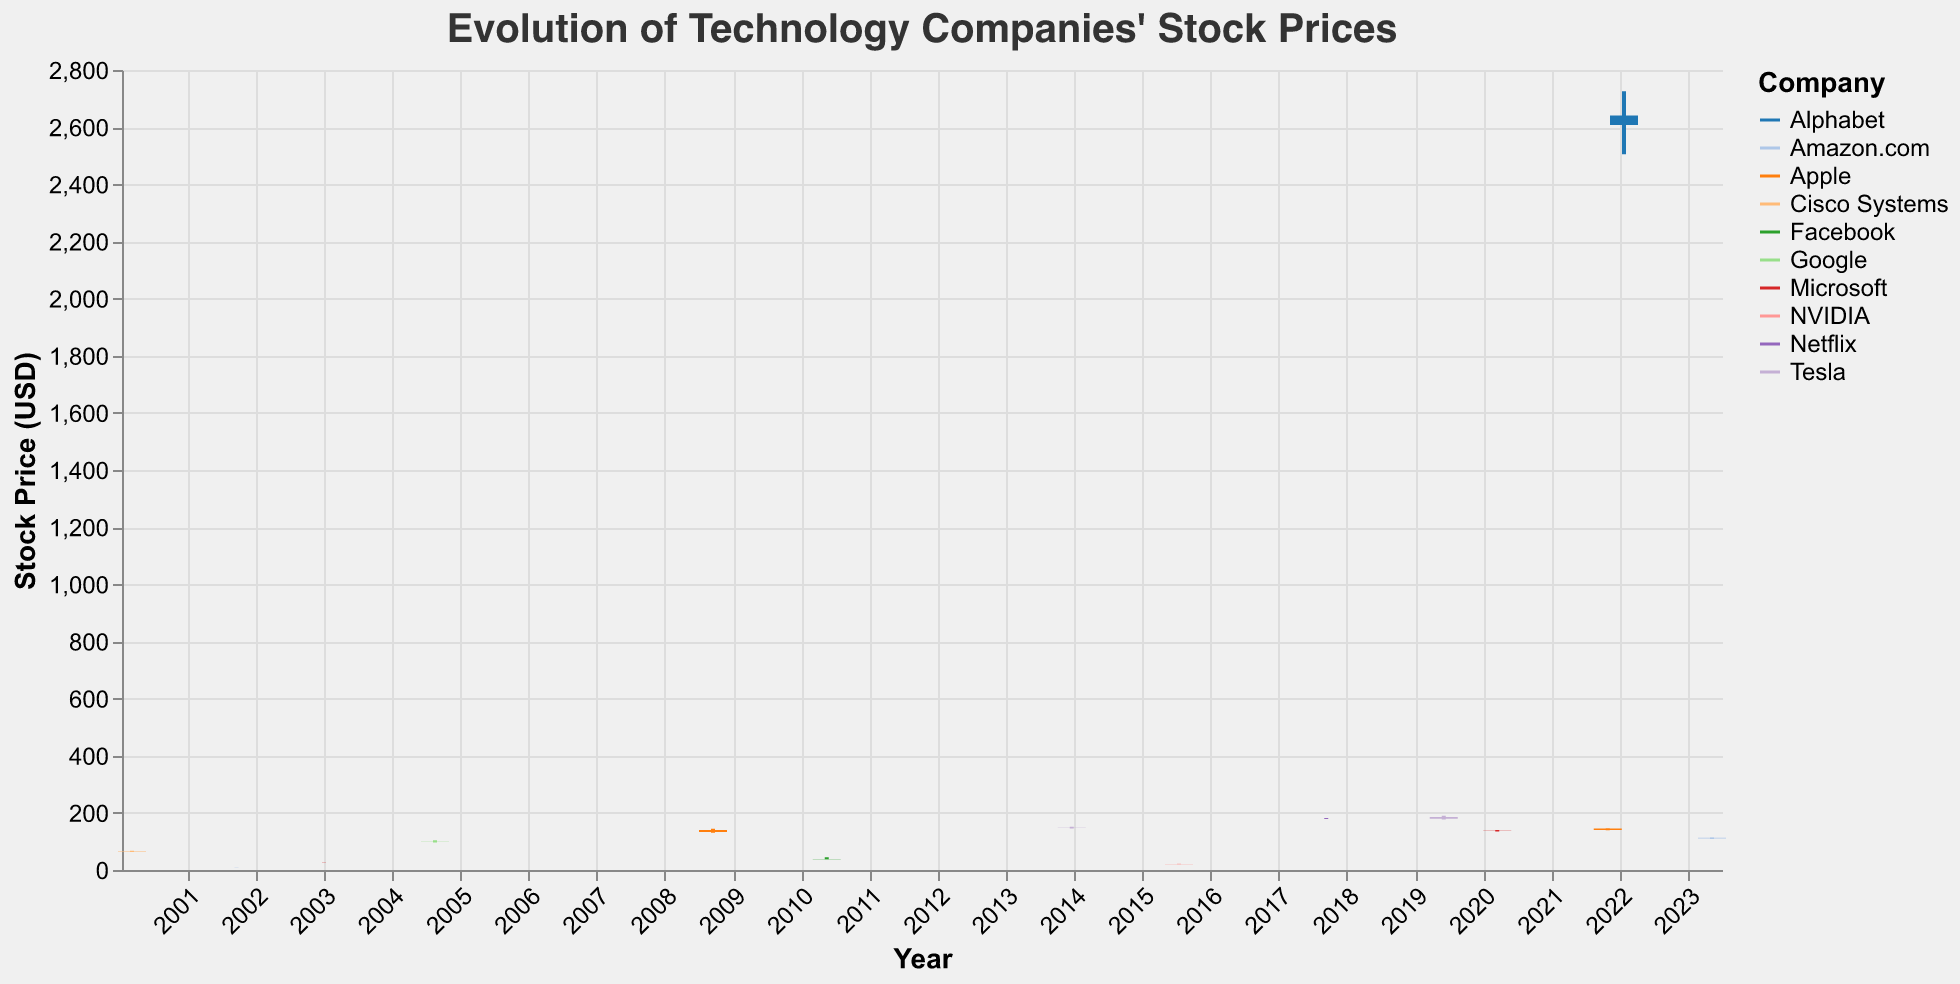What's the title of the figure? The title is usually placed at the top of the figure and describes what the data is about. In this case, the title is "Evolution of Technology Companies' Stock Prices".
Answer: Evolution of Technology Companies' Stock Prices What was the highest closing price for Alphabet, and when did it occur? Alphabet's data point is marked by the company's name and is associated with the highest stock price in the closing column. Find the closing price of 2607.44 on 2022-01-24.
Answer: 2607.44 on 2022-01-24 Which company had a lower closing price in March 2020, Microsoft or Tesla? Look at the closing prices for Microsoft and Tesla in March 2020. Microsoft's closing price on 2020-03-16 is 137.35, and Tesla does not have a data point for March 2020 in the figure, so it is absent.
Answer: Microsoft Which company experienced the most significant increase in stock price from its opening to closing price on the same day? Calculate the difference between the opening and closing prices for all companies. The one with the largest positive difference indicates the most significant increase. For example, Facebook on 2010-05-18 opened at 38.00 and closed at 38.23 with a minimal increase.
Answer: Alphabet on 2022-01-24 (difference of -32.99) Compare the stock price volatility of Apple on 2008-09-15 and on 2021-10-29. Which date had higher volatility? Volatility can be measured by the difference between the high and low prices for the day. For Apple on 2008-09-15: 144.18 - 130.00 = 14.18. On 2021-10-29: 145.09 - 139.30 = 5.79.
Answer: 2008-09-15 What was the volume of trades for Tesla on 2019-06-03, and how does it compare to NVIDIA's volume on 2015-07-17? The volume of trades for Tesla on 2019-06-03 is 62006100, and for NVIDIA on 2015-07-17 is 40000000. Comparing the two: 62006100 - 40000000 = 22006100 more trades for Tesla.
Answer: Tesla's volume was higher by 22006100 Identify the company with the lowest closing price in the data provided. Look at the closing prices for all companies and identify the lowest value. Amazon.com had a closing price of 8.40 on 2001-09-21, which is the lowest.
Answer: Amazon.com 